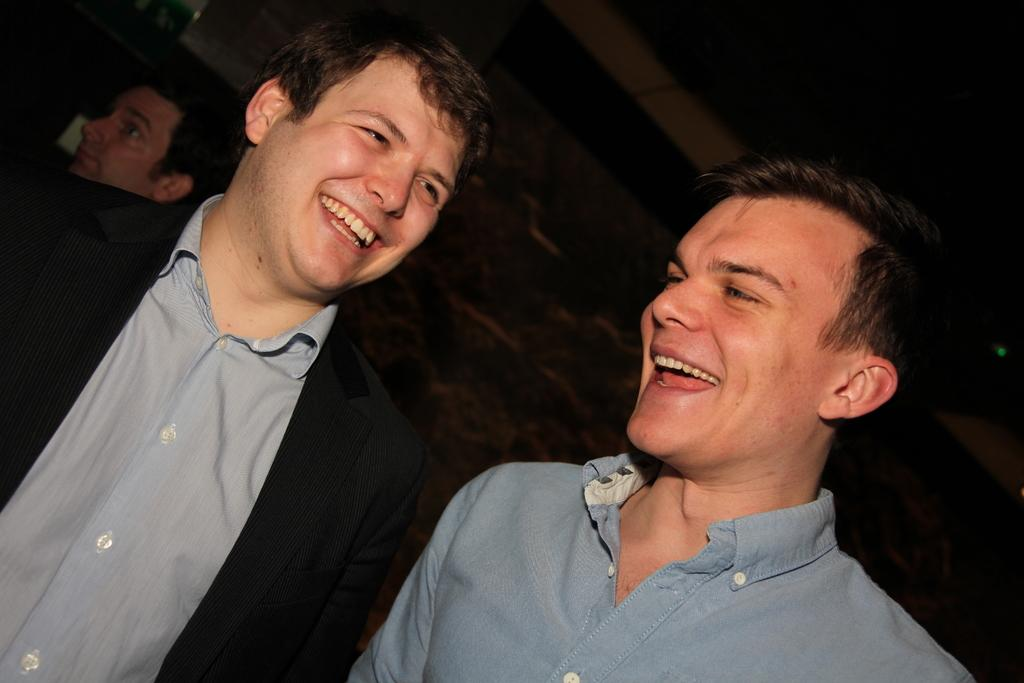What is the main subject of the image? The main subject of the image is a group of people. Can you describe the two men in the middle of the image? Both men are present in the middle of the image, and they are smiling. How many deer can be seen in the image? There are no deer present in the image. What type of liquid is being consumed by the group of people in the image? The provided facts do not mention any liquid being consumed by the group of people in the image. 